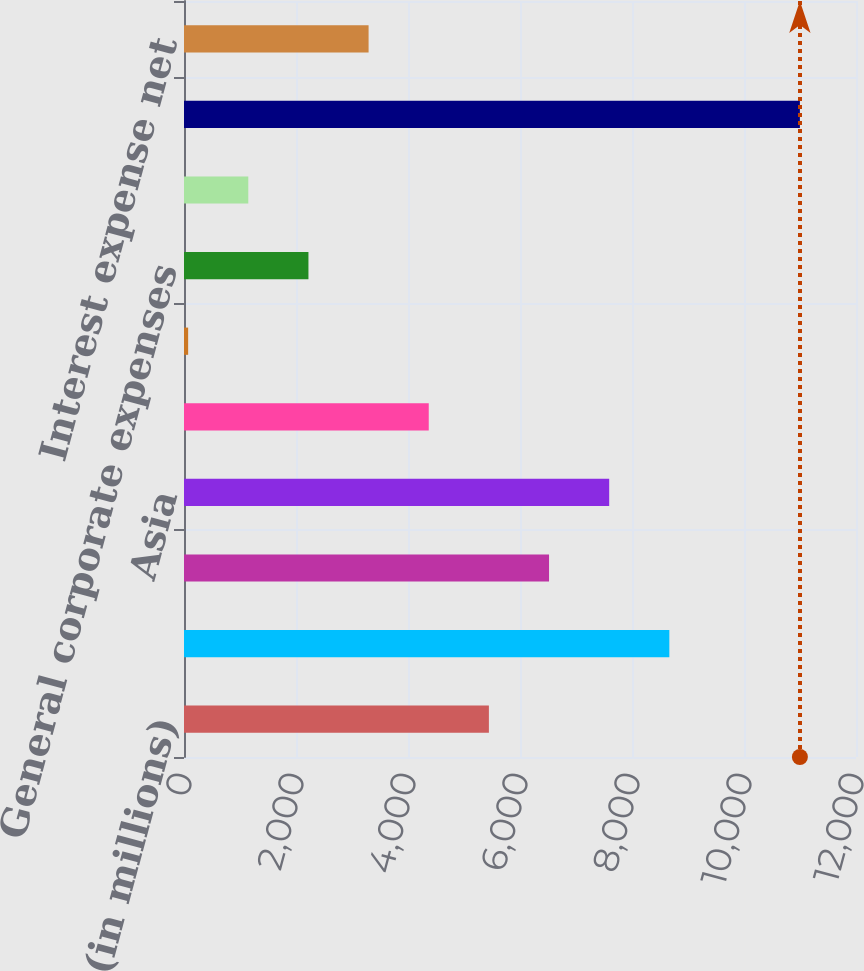Convert chart to OTSL. <chart><loc_0><loc_0><loc_500><loc_500><bar_chart><fcel>(in millions)<fcel>European Union<fcel>Eastern Europe Middle East &<fcel>Asia<fcel>Latin America & Canada<fcel>Amortization of intangibles<fcel>General corporate expenses<fcel>Equity (income)/loss in<fcel>Operating income<fcel>Interest expense net<nl><fcel>5444.5<fcel>8666.8<fcel>6518.6<fcel>7592.7<fcel>4370.4<fcel>74<fcel>2222.2<fcel>1148.1<fcel>10998.1<fcel>3296.3<nl></chart> 